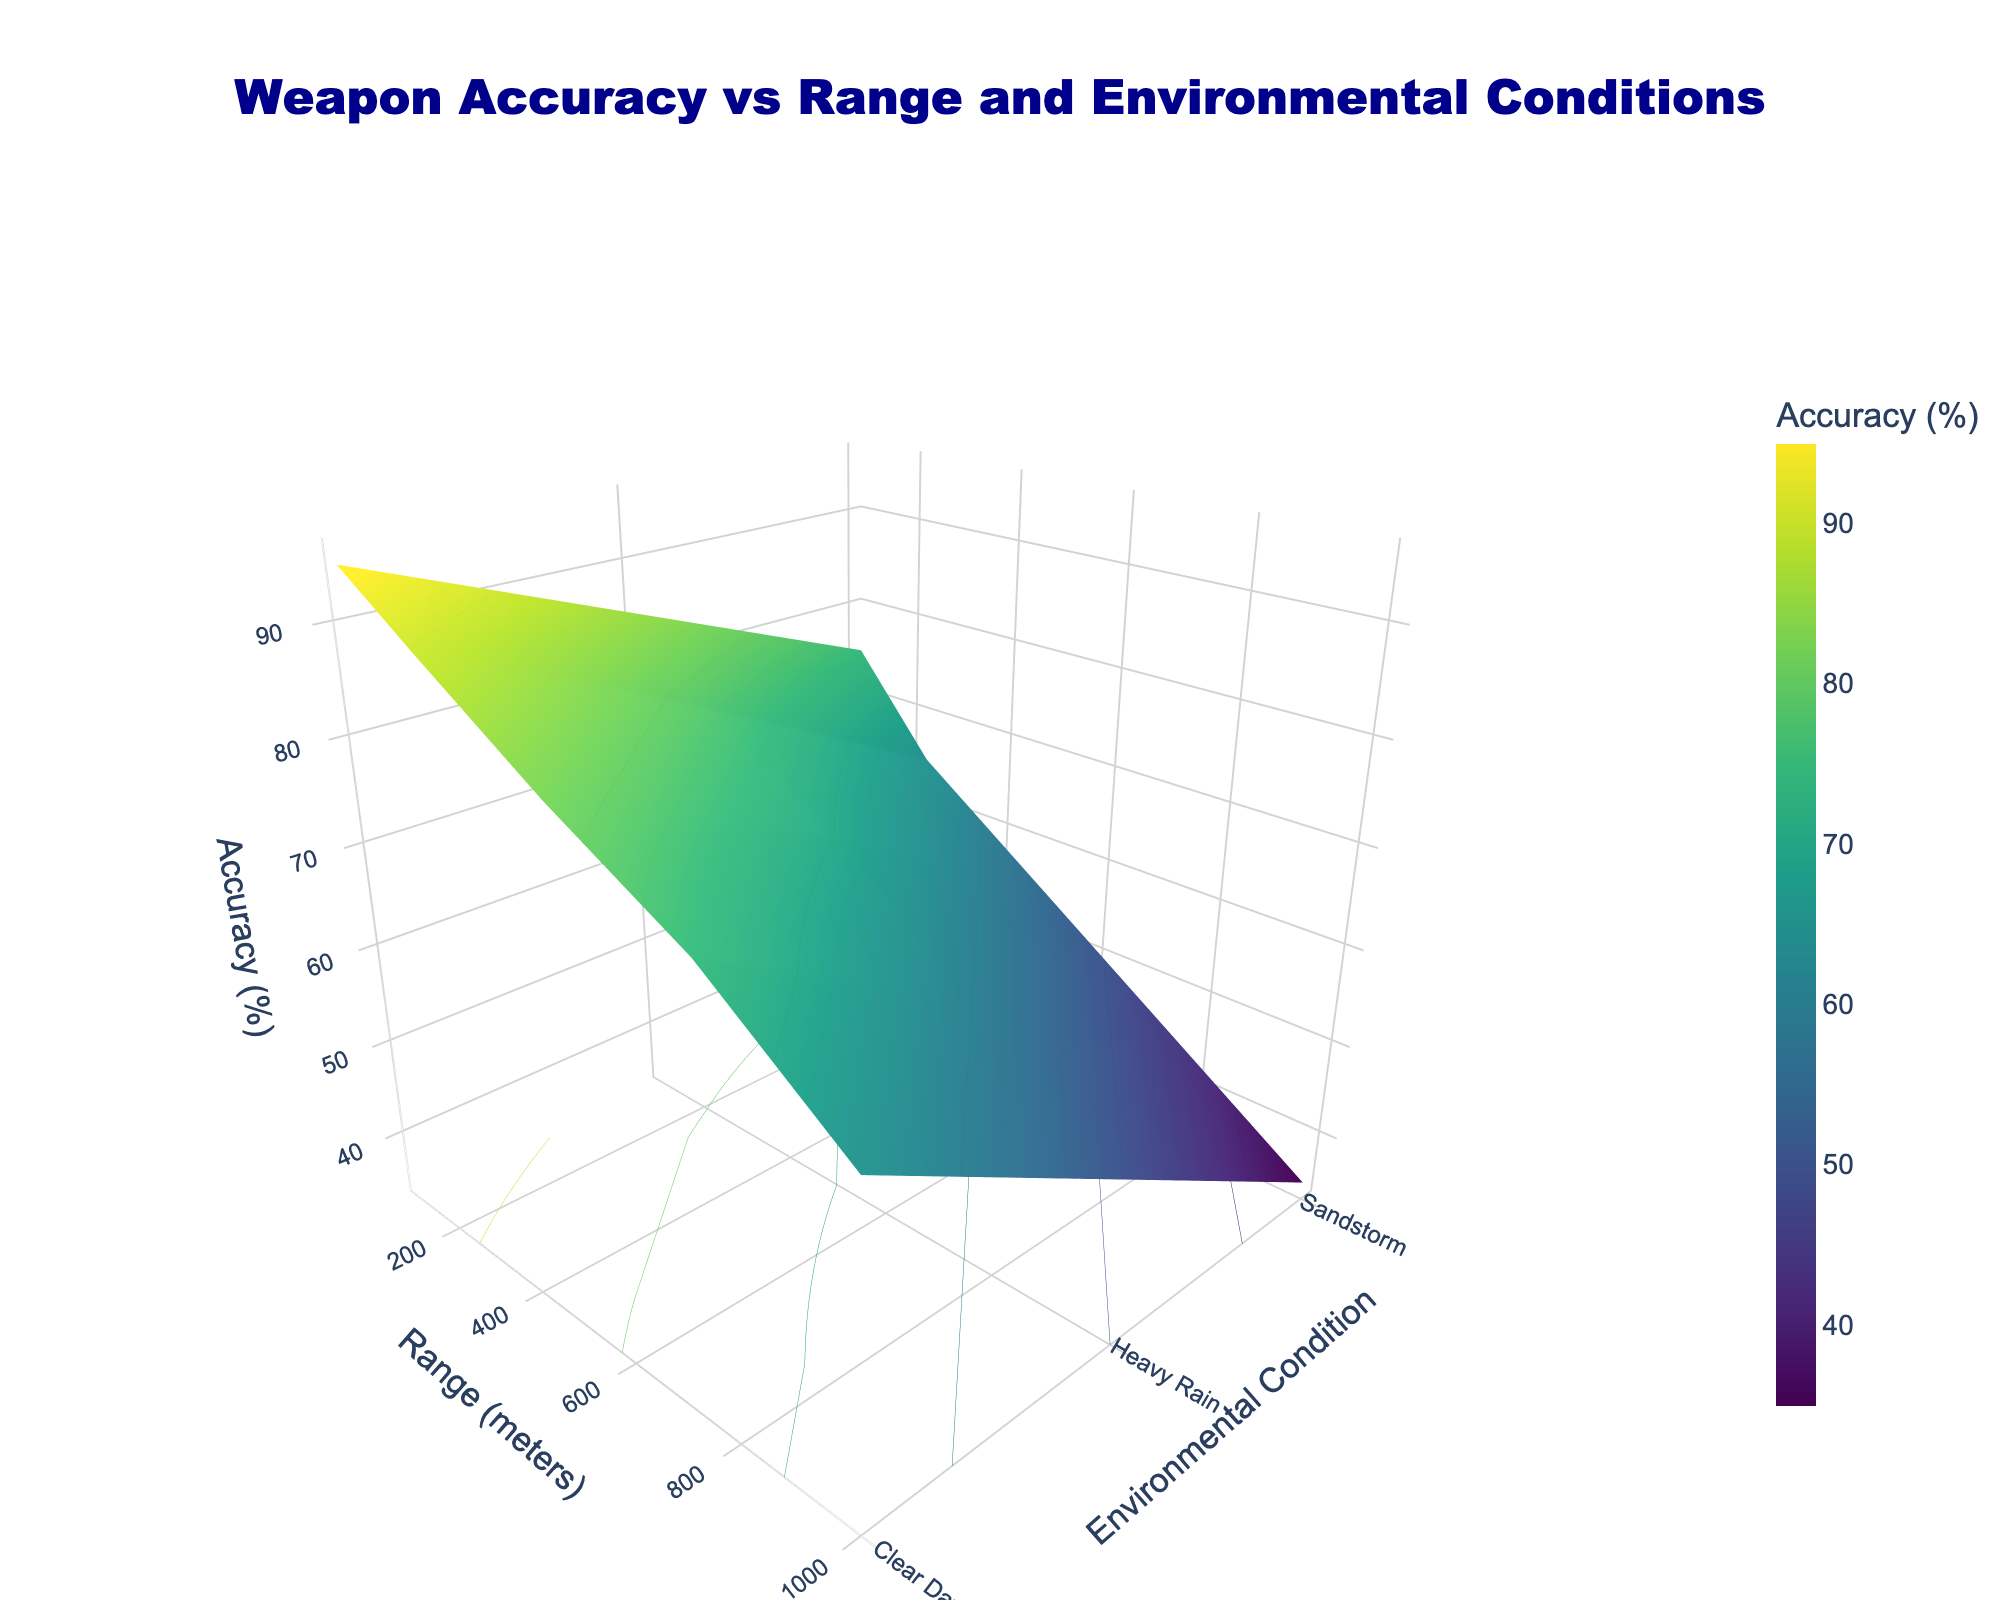What is the title of the figure? The title of the figure is located at the top of the chart. It reads "Weapon Accuracy vs Range and Environmental Conditions".
Answer: Weapon Accuracy vs Range and Environmental Conditions What are the three environmental conditions displayed? The y-axis represents environmental conditions. The three conditions shown are "Clear Day," "Heavy Rain," and "Sandstorm."
Answer: Clear Day, Heavy Rain, Sandstorm Which range shows the highest weapon accuracy in a Sandstorm? By observing the z-axis (accuracy) values for the "Sandstorm" condition across different ranges, the highest accuracy is achieved at 100 meters with 75%.
Answer: 100 meters How does weapon accuracy change from 100 to 1000 meters on a Clear Day? Tracking the z-axis (accuracy) values along the "Clear Day" condition from 100 to 1000 meters on the x-axis shows a decrease in accuracy: 95% at 100 meters, 90% at 250 meters, 82% at 500 meters, 75% at 750 meters, and 65% at 1000 meters.
Answer: It decreases What is the average weapon accuracy in Heavy Rain conditions? The z-axis (accuracy) values for the "Heavy Rain" condition at each range are: 85% (100 meters), 78% (250 meters), 70% (500 meters), 60% (750 meters), and 50% (1000 meters). The average is (85 + 78 + 70 + 60 + 50) / 5 = 68.6%.
Answer: 68.6% Which environmental condition has the lowest effectiveness at 500 meters? Comparing z-axis (accuracy) values at 500 meters for all environmental conditions, "Sandstorm" shows the lowest accuracy with 55%.
Answer: Sandstorm What is the accuracy difference between 750 and 100 meters during a Clear Day? The z-axis (accuracy) value for “Clear Day” at 750 meters is 75%, and at 100 meters it is 95%. The difference is 95% - 75% = 20%.
Answer: 20% Is weapon accuracy in Heavy Rain higher or lower than in a Sandstorm at 250 meters? By comparing z-axis (accuracy) values for "Heavy Rain" (78%) and "Sandstorm" (65%) at 250 meters, accuracy in Heavy Rain is higher.
Answer: Higher What is the trend of accuracy from Clear Day to Sandstorm at 500 meters? Following the z-axis (accuracy) values at 500 meters from "Clear Day" (82%), "Heavy Rain" (70%) to "Sandstorm" (55%), the accuracy shows a decreasing trend.
Answer: Decreasing 